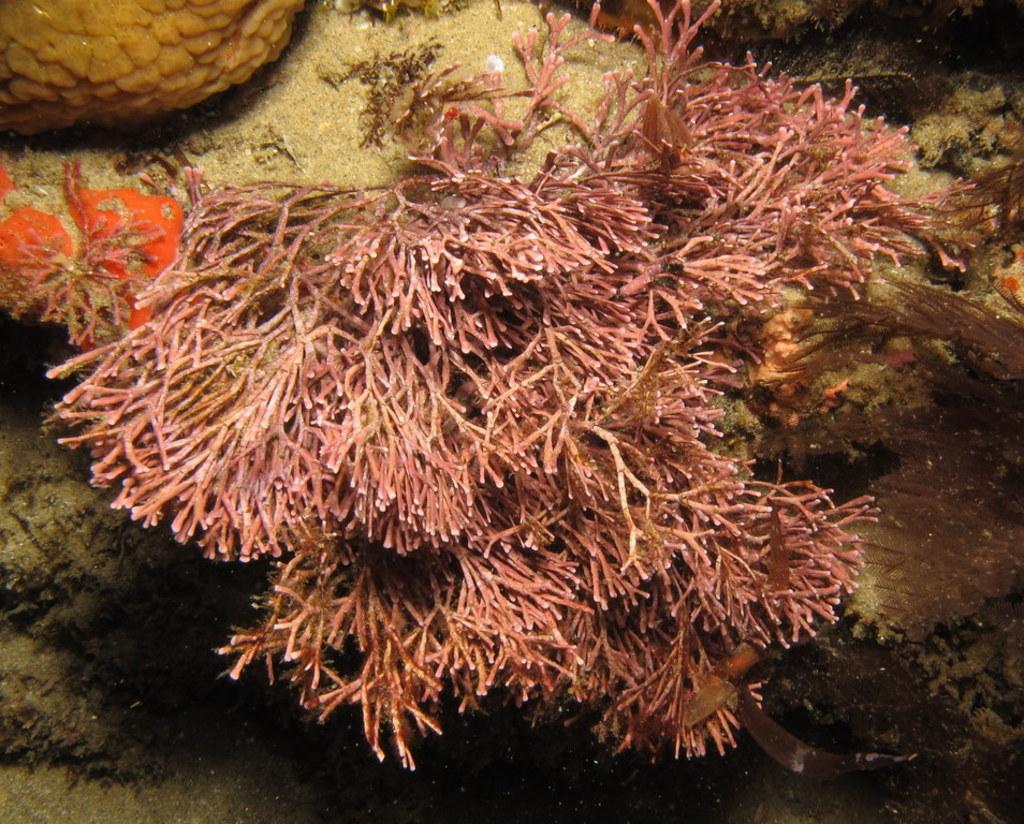Can you describe this image briefly? In this image we can see the sea grass underwater and some objects in the sea. 